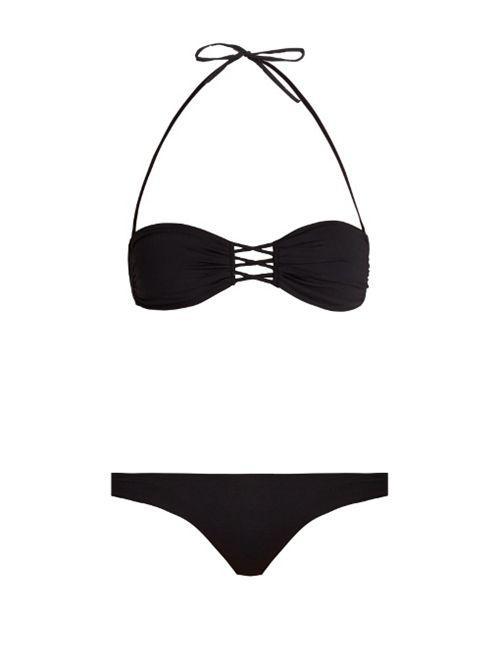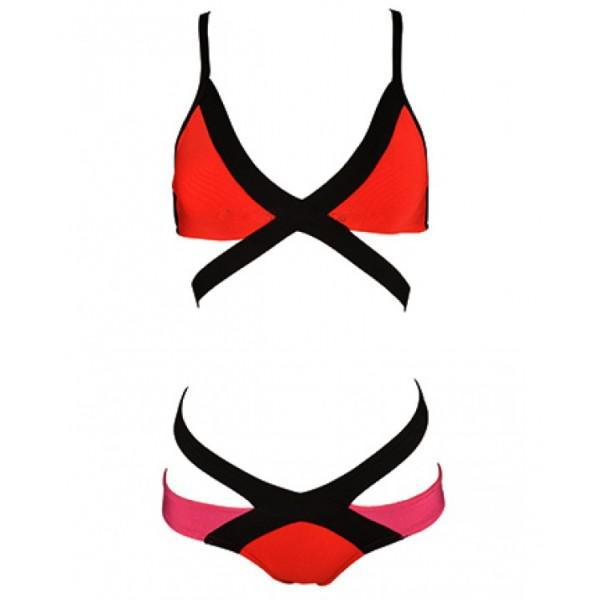The first image is the image on the left, the second image is the image on the right. Evaluate the accuracy of this statement regarding the images: "Both swimsuits are primarily black in color". Is it true? Answer yes or no. No. 